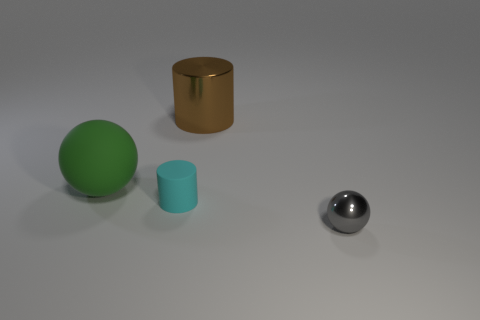Add 3 big purple matte spheres. How many objects exist? 7 Subtract 1 spheres. How many spheres are left? 1 Subtract all brown cylinders. How many cylinders are left? 1 Subtract 0 brown cubes. How many objects are left? 4 Subtract all brown spheres. Subtract all green cylinders. How many spheres are left? 2 Subtract all small shiny things. Subtract all cyan matte cylinders. How many objects are left? 2 Add 4 large shiny cylinders. How many large shiny cylinders are left? 5 Add 4 purple metallic cubes. How many purple metallic cubes exist? 4 